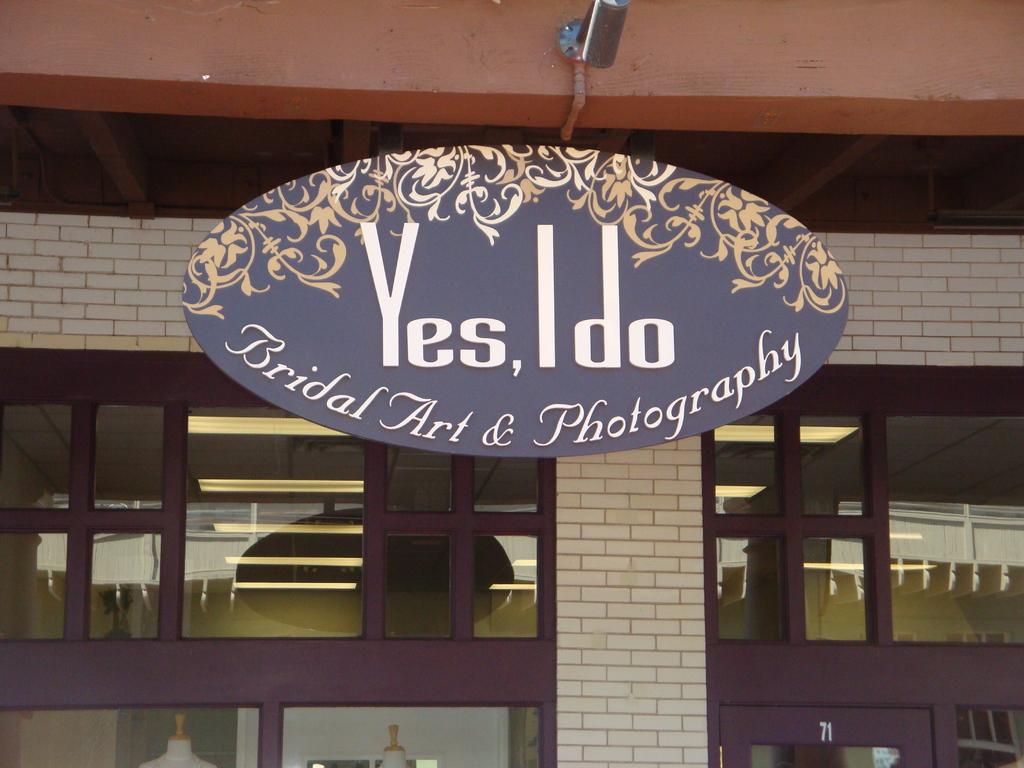What is the name of this company?
Your answer should be very brief. Yes, i do. What type of company is this?
Give a very brief answer. Bridal art & photography. 